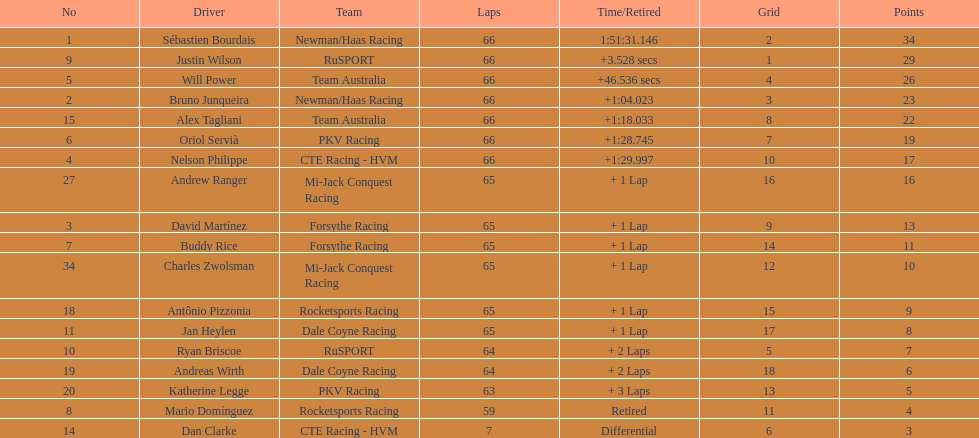Rice ended up 10th. who concluded subsequently? Charles Zwolsman. 